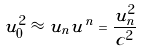<formula> <loc_0><loc_0><loc_500><loc_500>u _ { 0 } ^ { 2 } \approx u _ { n } u ^ { n } = \frac { u _ { n } ^ { 2 } } { c ^ { 2 } }</formula> 